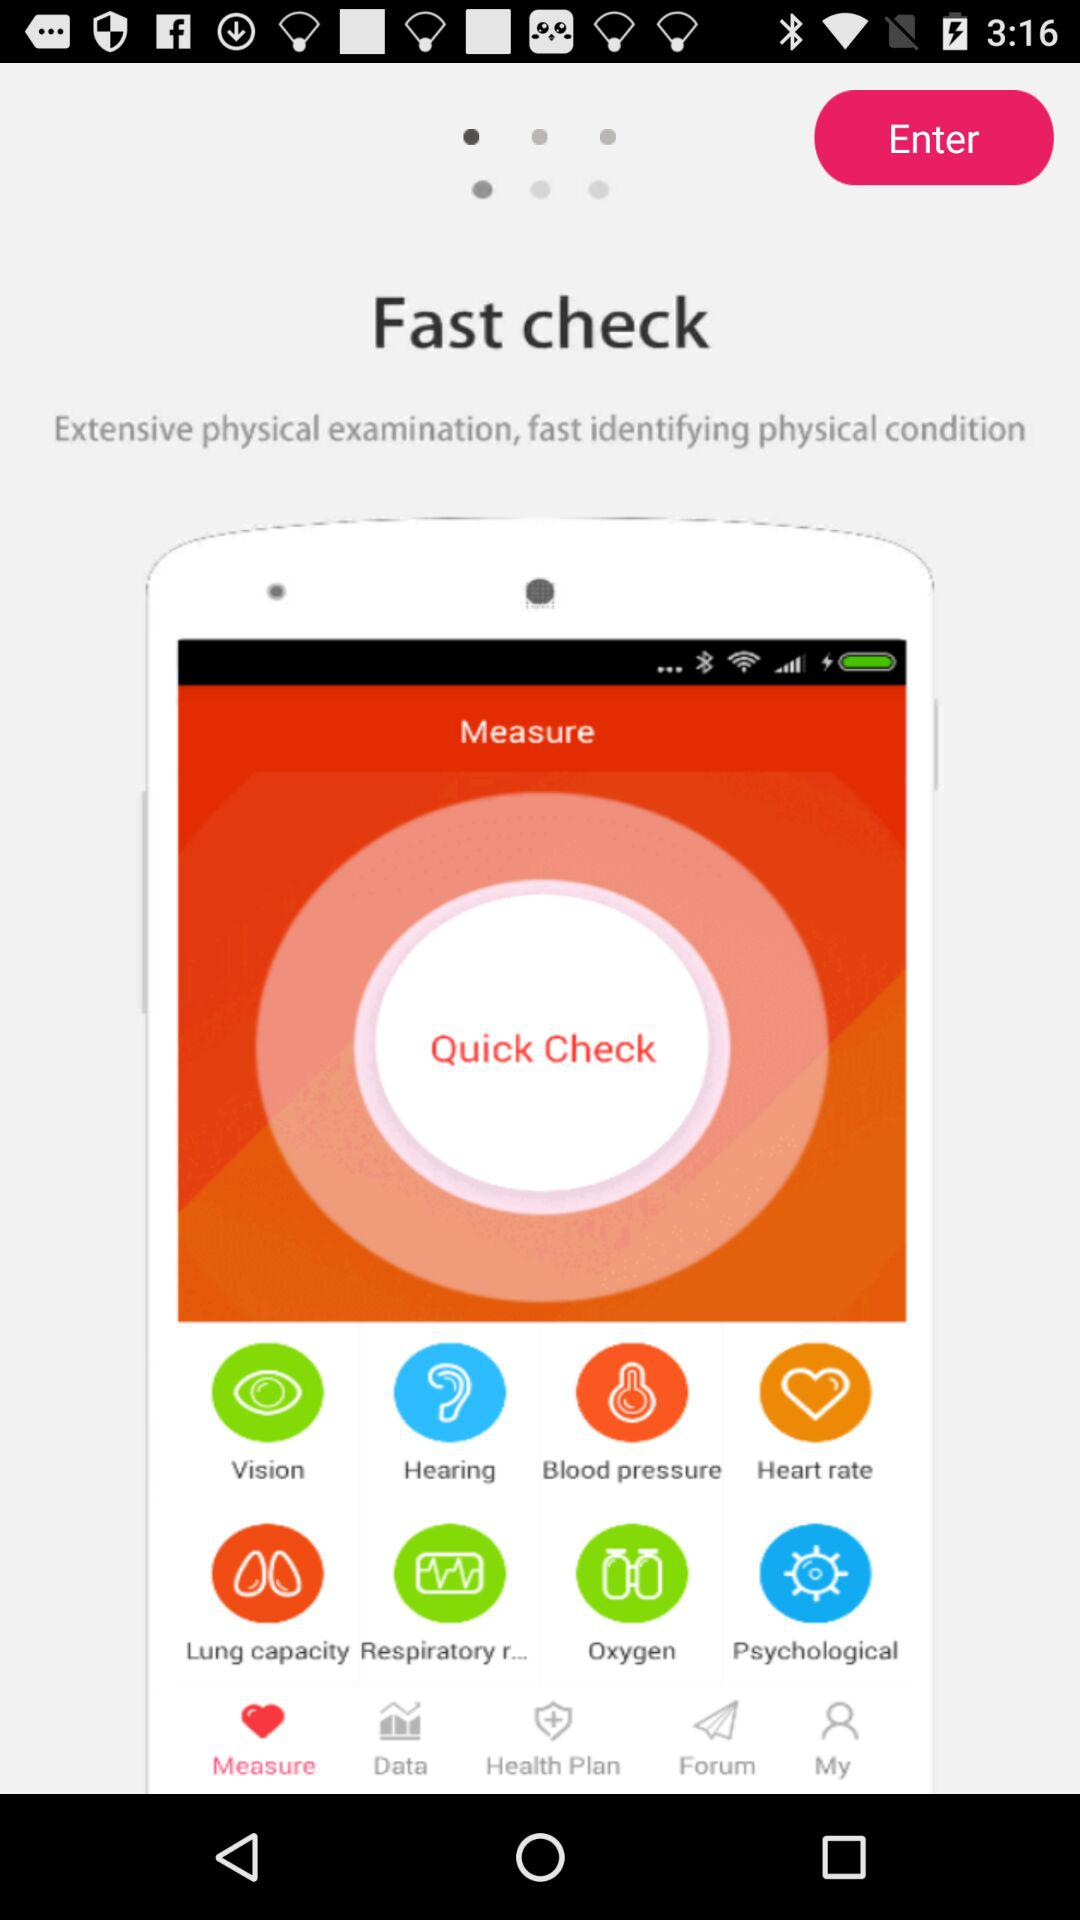What is the name of the application? The name of the application is "Fast check". 